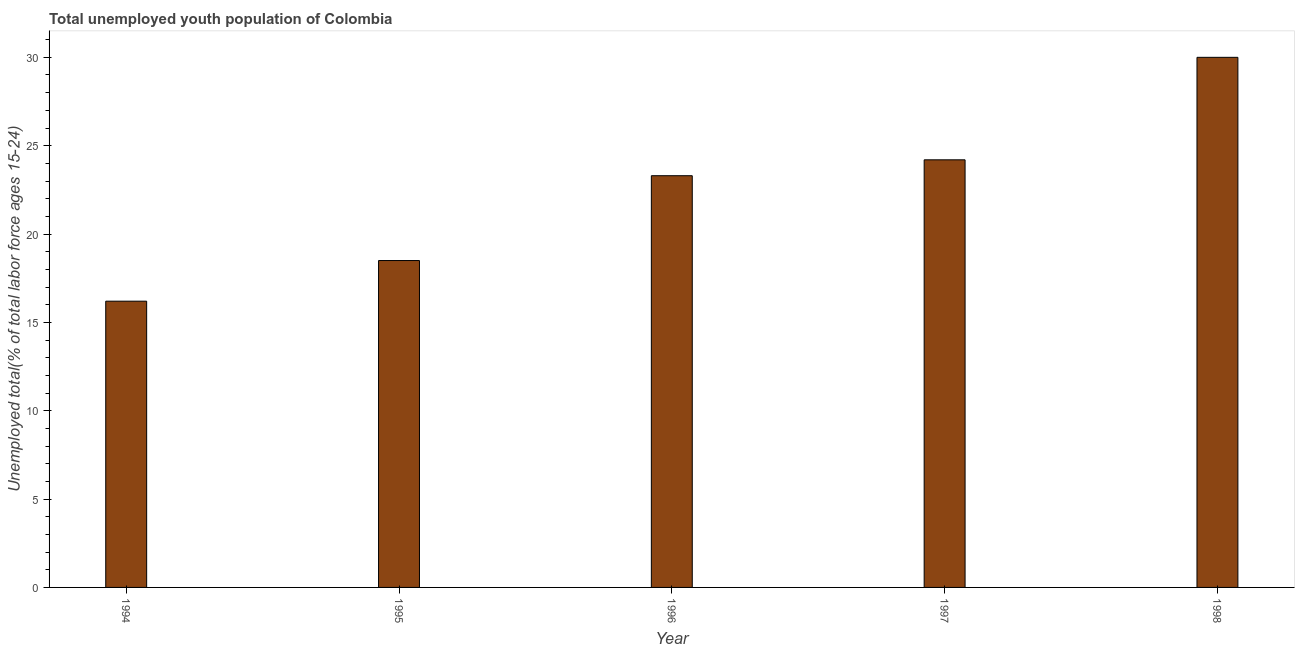Does the graph contain any zero values?
Provide a succinct answer. No. What is the title of the graph?
Your answer should be very brief. Total unemployed youth population of Colombia. What is the label or title of the Y-axis?
Offer a terse response. Unemployed total(% of total labor force ages 15-24). What is the unemployed youth in 1995?
Ensure brevity in your answer.  18.5. Across all years, what is the minimum unemployed youth?
Your answer should be very brief. 16.2. What is the sum of the unemployed youth?
Keep it short and to the point. 112.2. What is the difference between the unemployed youth in 1994 and 1996?
Keep it short and to the point. -7.1. What is the average unemployed youth per year?
Your answer should be very brief. 22.44. What is the median unemployed youth?
Provide a succinct answer. 23.3. Do a majority of the years between 1994 and 1996 (inclusive) have unemployed youth greater than 18 %?
Your answer should be compact. Yes. What is the ratio of the unemployed youth in 1995 to that in 1998?
Keep it short and to the point. 0.62. What is the difference between the highest and the second highest unemployed youth?
Your response must be concise. 5.8. Is the sum of the unemployed youth in 1995 and 1998 greater than the maximum unemployed youth across all years?
Provide a short and direct response. Yes. How many bars are there?
Your answer should be very brief. 5. How many years are there in the graph?
Give a very brief answer. 5. What is the difference between two consecutive major ticks on the Y-axis?
Your answer should be very brief. 5. What is the Unemployed total(% of total labor force ages 15-24) in 1994?
Provide a succinct answer. 16.2. What is the Unemployed total(% of total labor force ages 15-24) of 1995?
Make the answer very short. 18.5. What is the Unemployed total(% of total labor force ages 15-24) in 1996?
Make the answer very short. 23.3. What is the Unemployed total(% of total labor force ages 15-24) of 1997?
Your response must be concise. 24.2. What is the Unemployed total(% of total labor force ages 15-24) of 1998?
Provide a succinct answer. 30. What is the difference between the Unemployed total(% of total labor force ages 15-24) in 1994 and 1997?
Provide a succinct answer. -8. What is the difference between the Unemployed total(% of total labor force ages 15-24) in 1994 and 1998?
Offer a terse response. -13.8. What is the difference between the Unemployed total(% of total labor force ages 15-24) in 1995 and 1996?
Offer a terse response. -4.8. What is the difference between the Unemployed total(% of total labor force ages 15-24) in 1995 and 1998?
Your answer should be compact. -11.5. What is the difference between the Unemployed total(% of total labor force ages 15-24) in 1996 and 1997?
Your response must be concise. -0.9. What is the difference between the Unemployed total(% of total labor force ages 15-24) in 1996 and 1998?
Your answer should be compact. -6.7. What is the ratio of the Unemployed total(% of total labor force ages 15-24) in 1994 to that in 1995?
Provide a succinct answer. 0.88. What is the ratio of the Unemployed total(% of total labor force ages 15-24) in 1994 to that in 1996?
Your answer should be compact. 0.69. What is the ratio of the Unemployed total(% of total labor force ages 15-24) in 1994 to that in 1997?
Offer a very short reply. 0.67. What is the ratio of the Unemployed total(% of total labor force ages 15-24) in 1994 to that in 1998?
Provide a short and direct response. 0.54. What is the ratio of the Unemployed total(% of total labor force ages 15-24) in 1995 to that in 1996?
Offer a very short reply. 0.79. What is the ratio of the Unemployed total(% of total labor force ages 15-24) in 1995 to that in 1997?
Offer a very short reply. 0.76. What is the ratio of the Unemployed total(% of total labor force ages 15-24) in 1995 to that in 1998?
Offer a terse response. 0.62. What is the ratio of the Unemployed total(% of total labor force ages 15-24) in 1996 to that in 1998?
Your response must be concise. 0.78. What is the ratio of the Unemployed total(% of total labor force ages 15-24) in 1997 to that in 1998?
Provide a short and direct response. 0.81. 